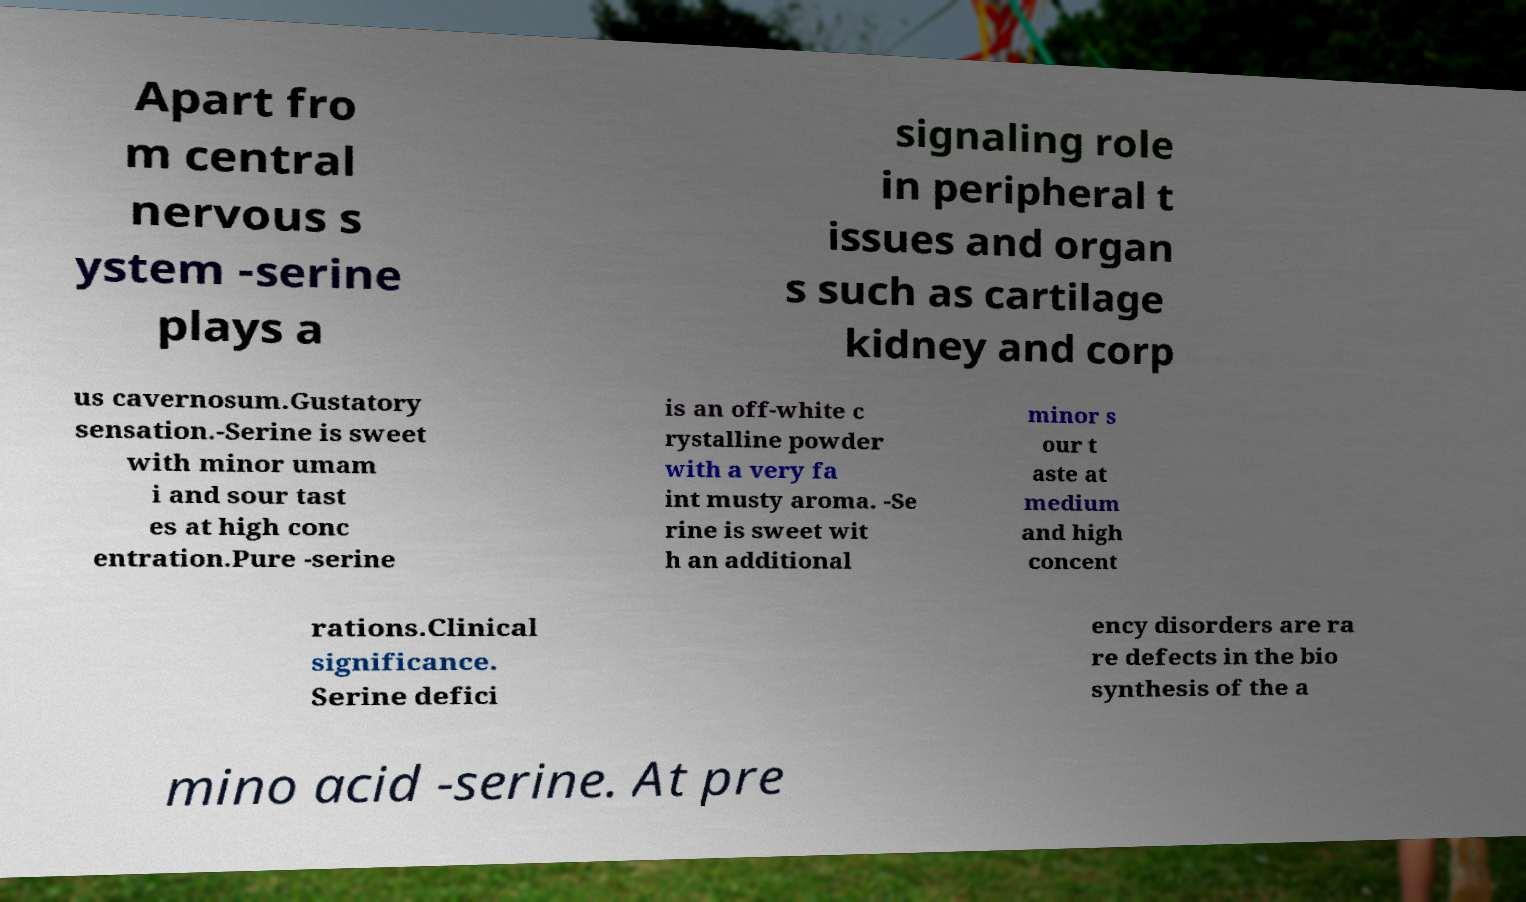Can you read and provide the text displayed in the image?This photo seems to have some interesting text. Can you extract and type it out for me? Apart fro m central nervous s ystem -serine plays a signaling role in peripheral t issues and organ s such as cartilage kidney and corp us cavernosum.Gustatory sensation.-Serine is sweet with minor umam i and sour tast es at high conc entration.Pure -serine is an off-white c rystalline powder with a very fa int musty aroma. -Se rine is sweet wit h an additional minor s our t aste at medium and high concent rations.Clinical significance. Serine defici ency disorders are ra re defects in the bio synthesis of the a mino acid -serine. At pre 